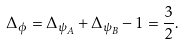<formula> <loc_0><loc_0><loc_500><loc_500>\Delta _ { \phi } = \Delta _ { \psi _ { A } } + \Delta _ { \psi _ { B } } - 1 = \frac { 3 } { 2 } .</formula> 